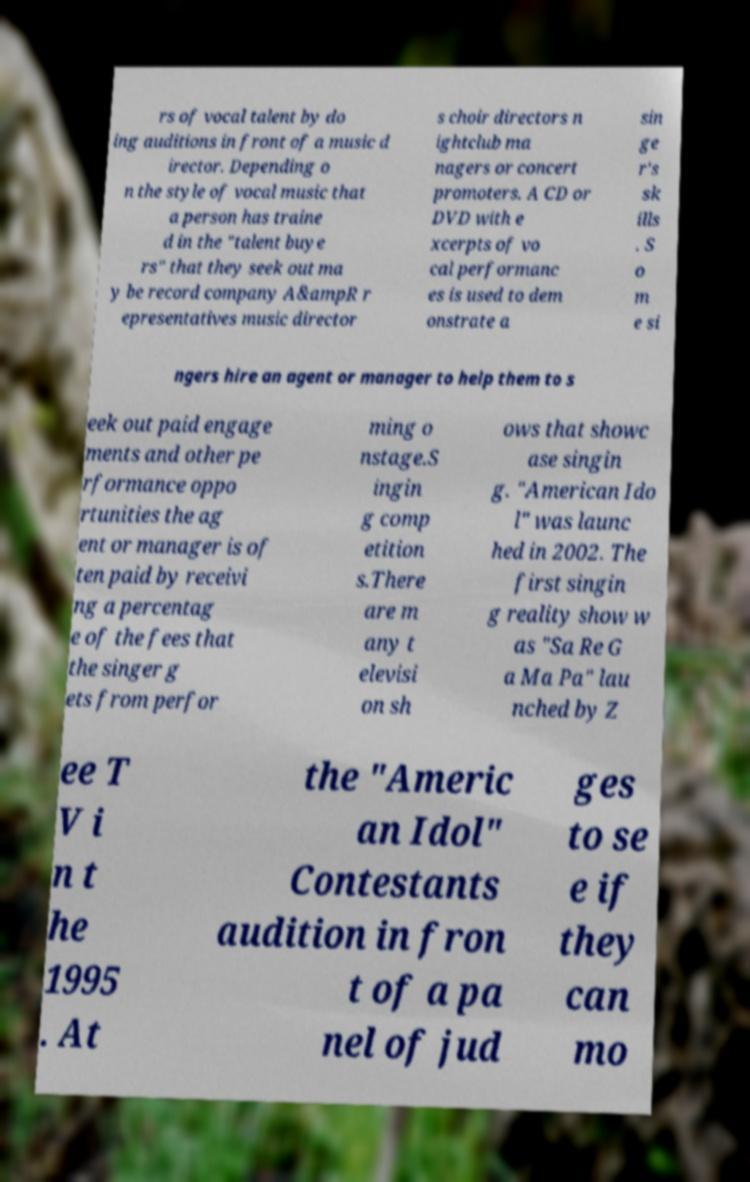Could you assist in decoding the text presented in this image and type it out clearly? rs of vocal talent by do ing auditions in front of a music d irector. Depending o n the style of vocal music that a person has traine d in the "talent buye rs" that they seek out ma y be record company A&ampR r epresentatives music director s choir directors n ightclub ma nagers or concert promoters. A CD or DVD with e xcerpts of vo cal performanc es is used to dem onstrate a sin ge r's sk ills . S o m e si ngers hire an agent or manager to help them to s eek out paid engage ments and other pe rformance oppo rtunities the ag ent or manager is of ten paid by receivi ng a percentag e of the fees that the singer g ets from perfor ming o nstage.S ingin g comp etition s.There are m any t elevisi on sh ows that showc ase singin g. "American Ido l" was launc hed in 2002. The first singin g reality show w as "Sa Re G a Ma Pa" lau nched by Z ee T V i n t he 1995 . At the "Americ an Idol" Contestants audition in fron t of a pa nel of jud ges to se e if they can mo 